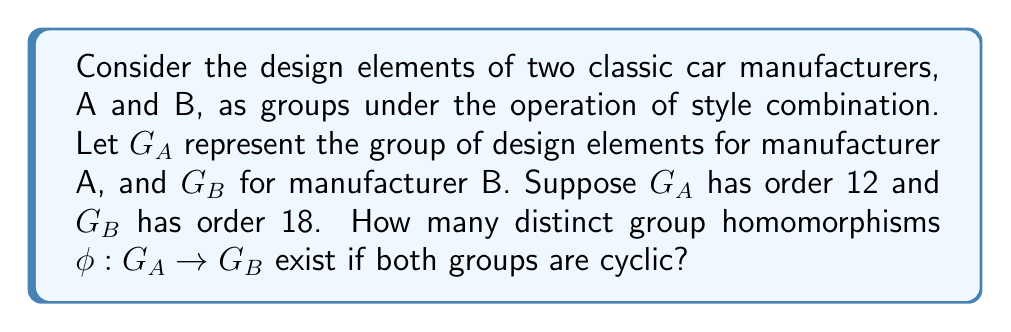What is the answer to this math problem? To solve this problem, we'll follow these steps:

1) First, recall that for cyclic groups, the number of homomorphisms depends on the orders of the groups and their greatest common divisor (GCD).

2) Let $|G_A| = n$ and $|G_B| = m$. The number of homomorphisms from $G_A$ to $G_B$ is equal to the number of elements in $G_B$ whose order divides $n$.

3) In this case, $n = 12$ and $m = 18$.

4) We need to find $\gcd(12, 18)$:
   $18 = 1 \times 12 + 6$
   $12 = 2 \times 6 + 0$
   Therefore, $\gcd(12, 18) = 6$

5) The possible orders of elements in $G_B$ that divide 12 are: 1, 2, 3, 6, 12.

6) Now, we need to count how many elements in $G_B$ have these orders:
   - Order 1: Only the identity element (1 element)
   - Order 2: $\phi(2) = 1$ element
   - Order 3: $\phi(3) = 2$ elements
   - Order 6: $\phi(6) = 2$ elements
   - Order 12: None, as 12 doesn't divide 18

7) The total number of homomorphisms is the sum of these counts:
   $1 + 1 + 2 + 2 = 6$

Here, $\phi(n)$ represents Euler's totient function, which counts the number of integers up to $n$ that are coprime to $n$.
Answer: There are 6 distinct group homomorphisms from $G_A$ to $G_B$. 